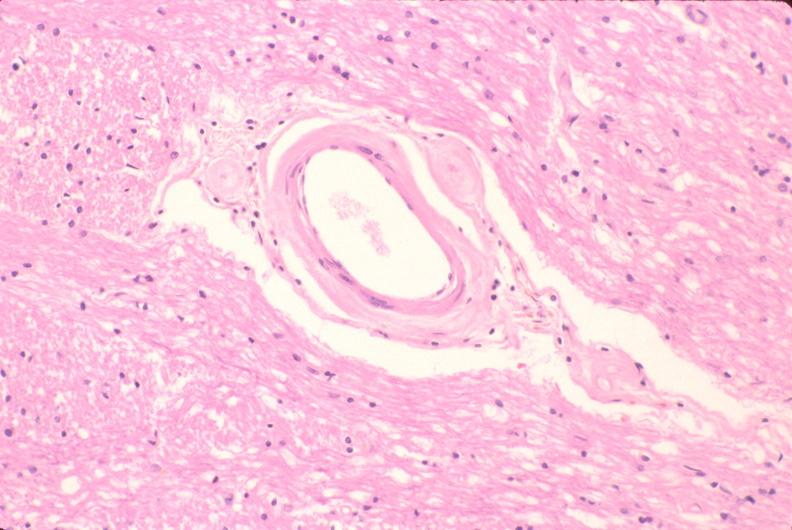what is present?
Answer the question using a single word or phrase. Nervous 